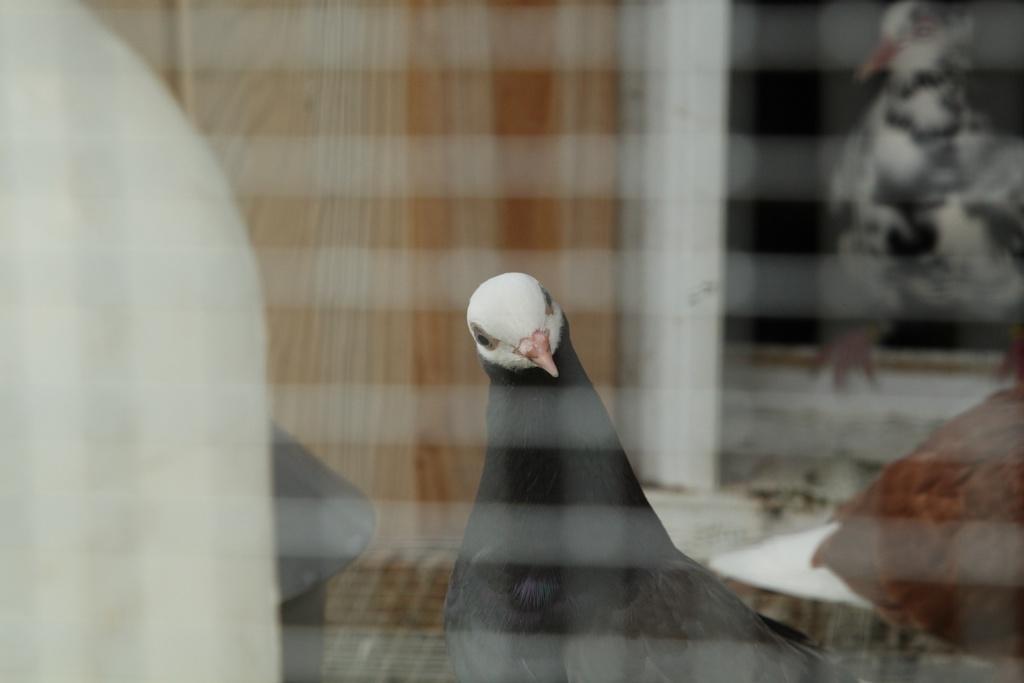Could you give a brief overview of what you see in this image? In the picture we can see a glass from it we can see a bird which is black in color with white face and beak and behind it we can see a curtain and window frame. 